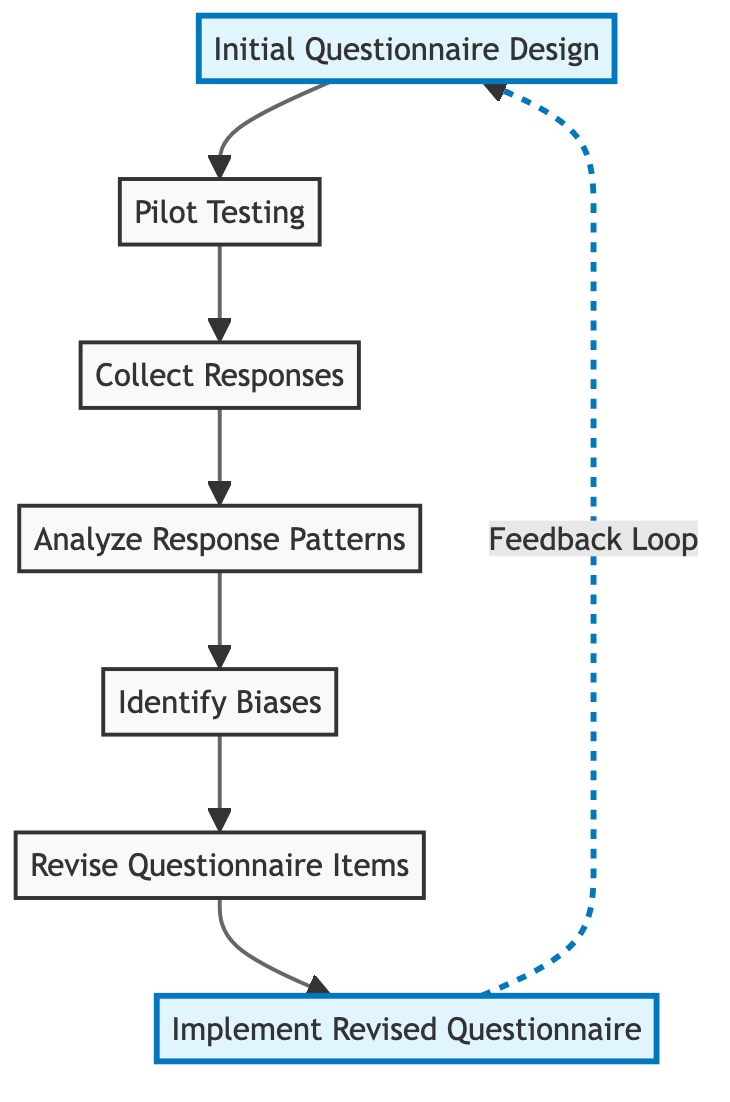What is the first step in the questionnaire development process? The first step in the process is represented by the node labeled "Initial Questionnaire Design," which is the starting point of the directed graph.
Answer: Initial Questionnaire Design How many nodes are in the diagram? By counting each unique step represented in the diagram, we find there are seven nodes detailing the questionnaire development process.
Answer: 7 What node follows "Pilot Testing"? The flow of the diagram indicates that "Collect Responses" directly follows "Pilot Testing," as represented by the edge connecting these two nodes.
Answer: Collect Responses Which step involves revising the questionnaire? The step where the revisions take place is clearly indicated by the node labeled "Revise Questionnaire Items," which follows after identifying biases.
Answer: Revise Questionnaire Items How does "Implement Revised Questionnaire" relate to "Initial Questionnaire Design"? The diagram illustrates a feedback loop where "Implement Revised Questionnaire" leads back to "Initial Questionnaire Design," indicating the cyclical nature of the process.
Answer: Feedback Loop What is the last step before implementing a revised questionnaire? The last step before implementation is "Revise Questionnaire Items," as indicated by the directed edge leading to the implementation stage.
Answer: Revise Questionnaire Items What is the relationship between "Analyze Response Patterns" and "Identify Biases"? The flow between these two nodes shows that "Analyze Response Patterns" directly informs the next step, which is "Identify Biases," creating a sequence in the questionnaire development process.
Answer: "Analyze Response Patterns" informs "Identify Biases" How many edges connect the nodes in the diagram? Counting all the directed connections (edges) shows that there are six edges linking the seven nodes together in the flow of the questionnaire development process.
Answer: 6 Which step occurs after collecting responses? The diagram indicates that following "Collect Responses," the next step is "Analyze Response Patterns," indicating the systematic progression of the process.
Answer: Analyze Response Patterns 